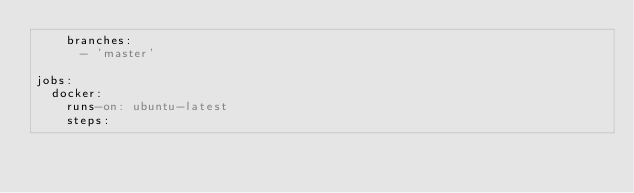<code> <loc_0><loc_0><loc_500><loc_500><_YAML_>    branches:
      - 'master'

jobs:
  docker:
    runs-on: ubuntu-latest
    steps:</code> 